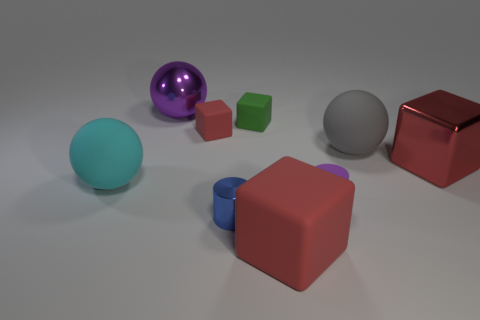Are any small yellow objects visible?
Your answer should be very brief. No. There is a large red thing that is behind the cyan rubber object; is its shape the same as the red matte thing that is in front of the red metallic block?
Your answer should be compact. Yes. What number of big things are either yellow cylinders or rubber spheres?
Offer a terse response. 2. What shape is the large cyan object that is the same material as the green thing?
Ensure brevity in your answer.  Sphere. Is the shape of the small green thing the same as the large gray thing?
Provide a short and direct response. No. The tiny metallic cylinder is what color?
Make the answer very short. Blue. What number of objects are either big cyan matte balls or large things?
Offer a very short reply. 5. Are there fewer blue things that are behind the big gray rubber ball than small yellow shiny spheres?
Provide a short and direct response. No. Are there more matte cubes that are behind the big purple metal thing than big gray rubber spheres that are to the left of the tiny red cube?
Offer a very short reply. No. Is there anything else of the same color as the shiny ball?
Your answer should be compact. Yes. 